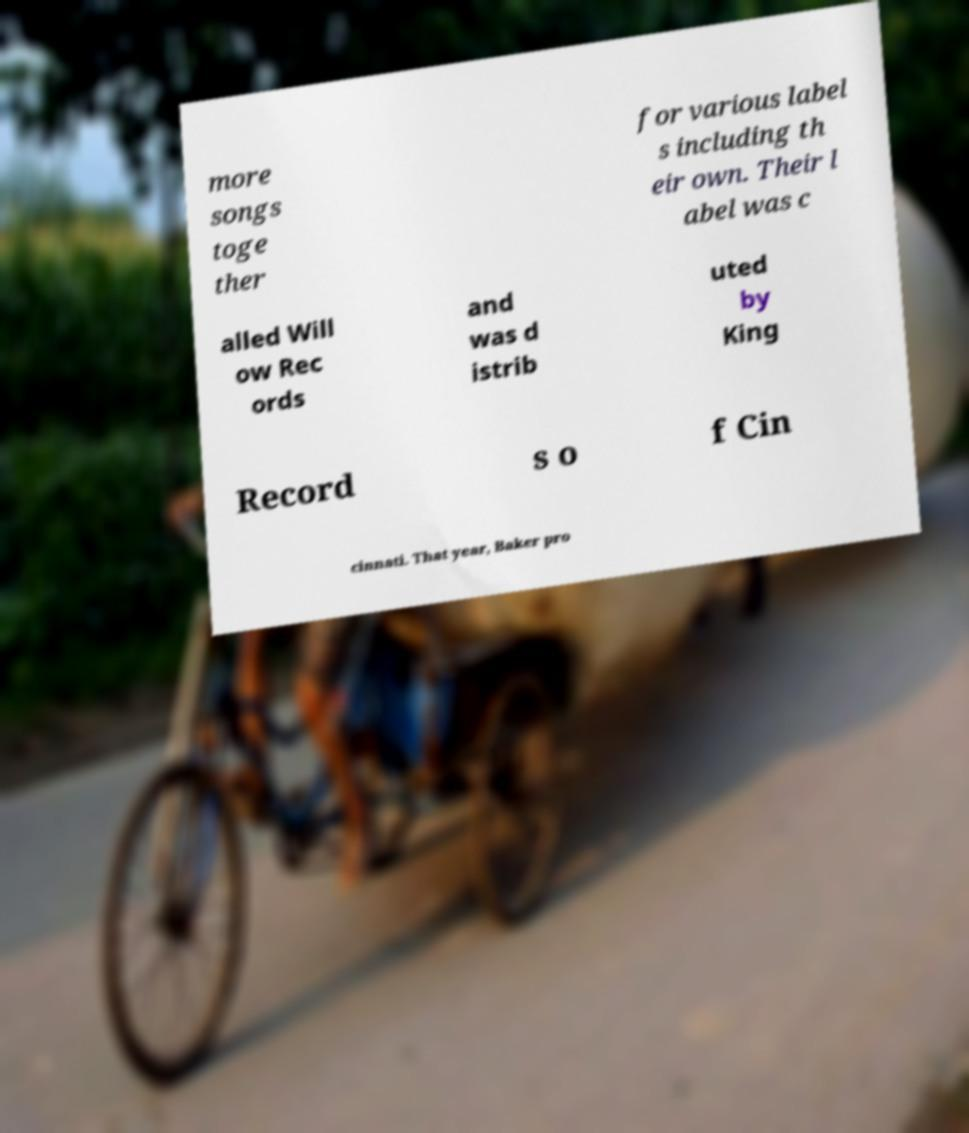Can you accurately transcribe the text from the provided image for me? more songs toge ther for various label s including th eir own. Their l abel was c alled Will ow Rec ords and was d istrib uted by King Record s o f Cin cinnati. That year, Baker pro 